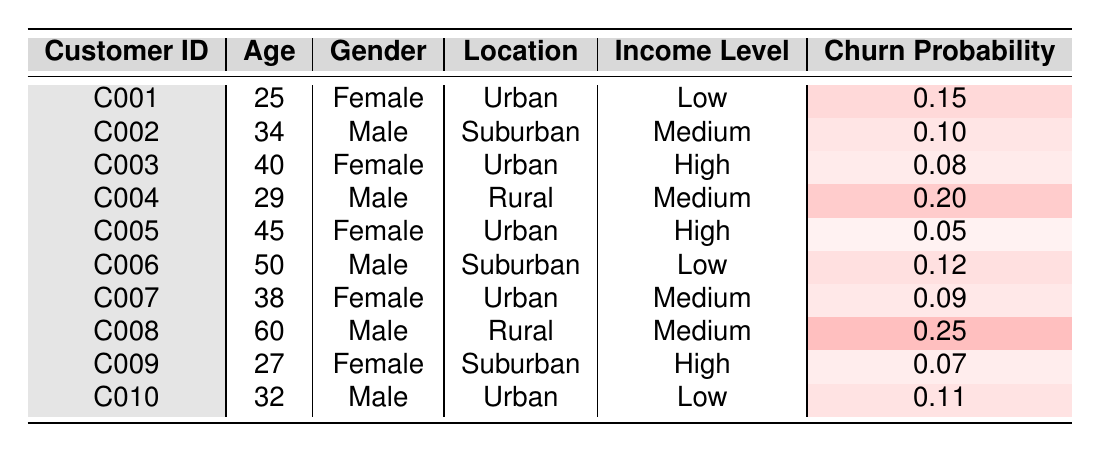What is the churn probability for the Male customer aged 50? The table shows that the Male customer aged 50 is identified as customer C006, with a churn probability of 0.12.
Answer: 0.12 Which customer has the highest churn probability? By checking each churn probability value, customer C008 has the highest churn probability of 0.25.
Answer: C008 Are there any Female customers with a churn probability lower than 0.10? Looking through the Female customers' rows, customers C003 (0.08), C005 (0.05), and C009 (0.07) all have churn probabilities lower than 0.10. Thus, the answer is yes.
Answer: Yes What is the average churn probability for customers residing in Urban areas? The customers in Urban areas are C001 (0.15), C003 (0.08), C005 (0.05), C007 (0.09), and C010 (0.11). The sum of these probabilities is 0.15 + 0.08 + 0.05 + 0.09 + 0.11 = 0.48, and there are 5 such customers, so the average is 0.48/5 = 0.096.
Answer: 0.096 Are all customers in the Rural location Male? Upon examining the table, customers C004 and C008 are the only Rural customers, and both are Male. Therefore, the statement is true.
Answer: Yes What is the churn probability difference between the youngest and the oldest customer? The youngest customer is C001 with a churn probability of 0.15, and the oldest customer is C008 with 0.25. The difference is 0.25 - 0.15 = 0.10.
Answer: 0.10 How many customers have a medium income level with a churn probability greater than 0.10? The customers C002, C004, C006, and C008 have medium income levels. Out of these, only C004 (0.20) and C008 (0.25) have probabilities greater than 0.10. Thus, there are 2 such customers.
Answer: 2 